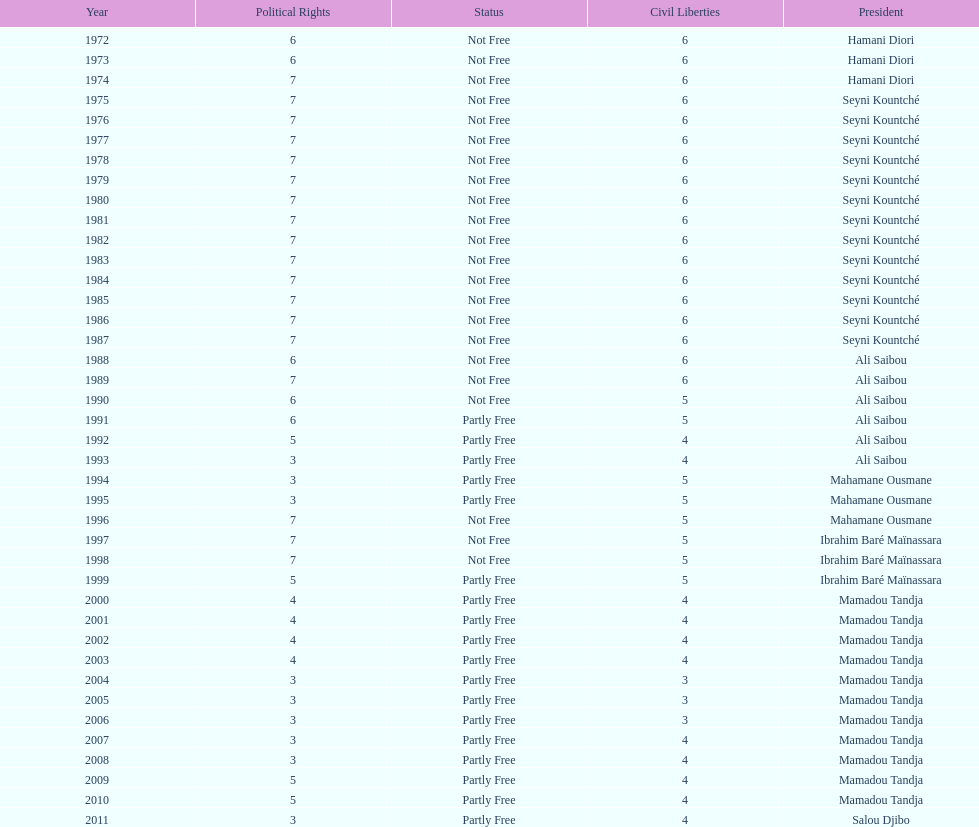How many years was it before the first partly free status? 18. 